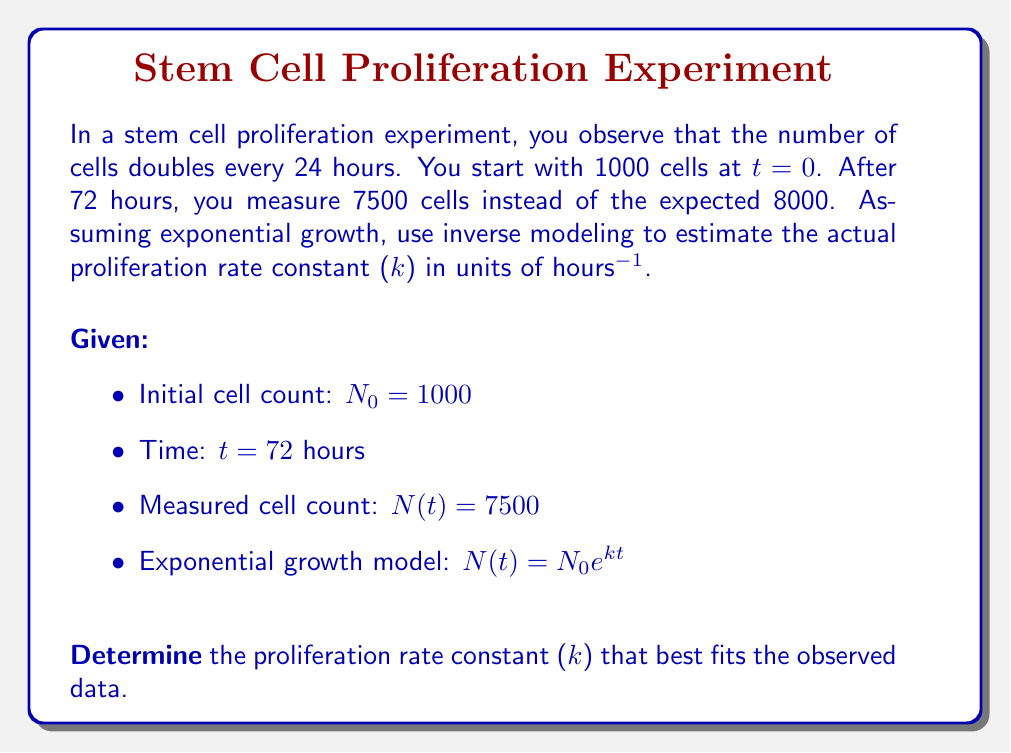Teach me how to tackle this problem. To solve this inverse problem, we'll follow these steps:

1) First, let's recall the exponential growth model:
   $N(t) = N_0 e^{kt}$

2) We know the initial conditions and the measured value:
   $N_0 = 1000$
   $t = 72$ hours
   $N(72) = 7500$

3) Substituting these values into the model:
   $7500 = 1000 e^{72k}$

4) Divide both sides by 1000:
   $7.5 = e^{72k}$

5) Take the natural logarithm of both sides:
   $\ln(7.5) = 72k$

6) Solve for k:
   $k = \frac{\ln(7.5)}{72}$

7) Calculate the value:
   $k = \frac{\ln(7.5)}{72} \approx 0.0283$ hours^(-1)

8) To verify, we can calculate the doubling time using this k:
   $t_{doubling} = \frac{\ln(2)}{k} = \frac{\ln(2)}{0.0283} \approx 24.5$ hours

This is close to the initial observation of doubling every 24 hours, but slightly longer, which explains why we observed fewer cells than expected after 72 hours.
Answer: $k \approx 0.0283$ hours^(-1) 